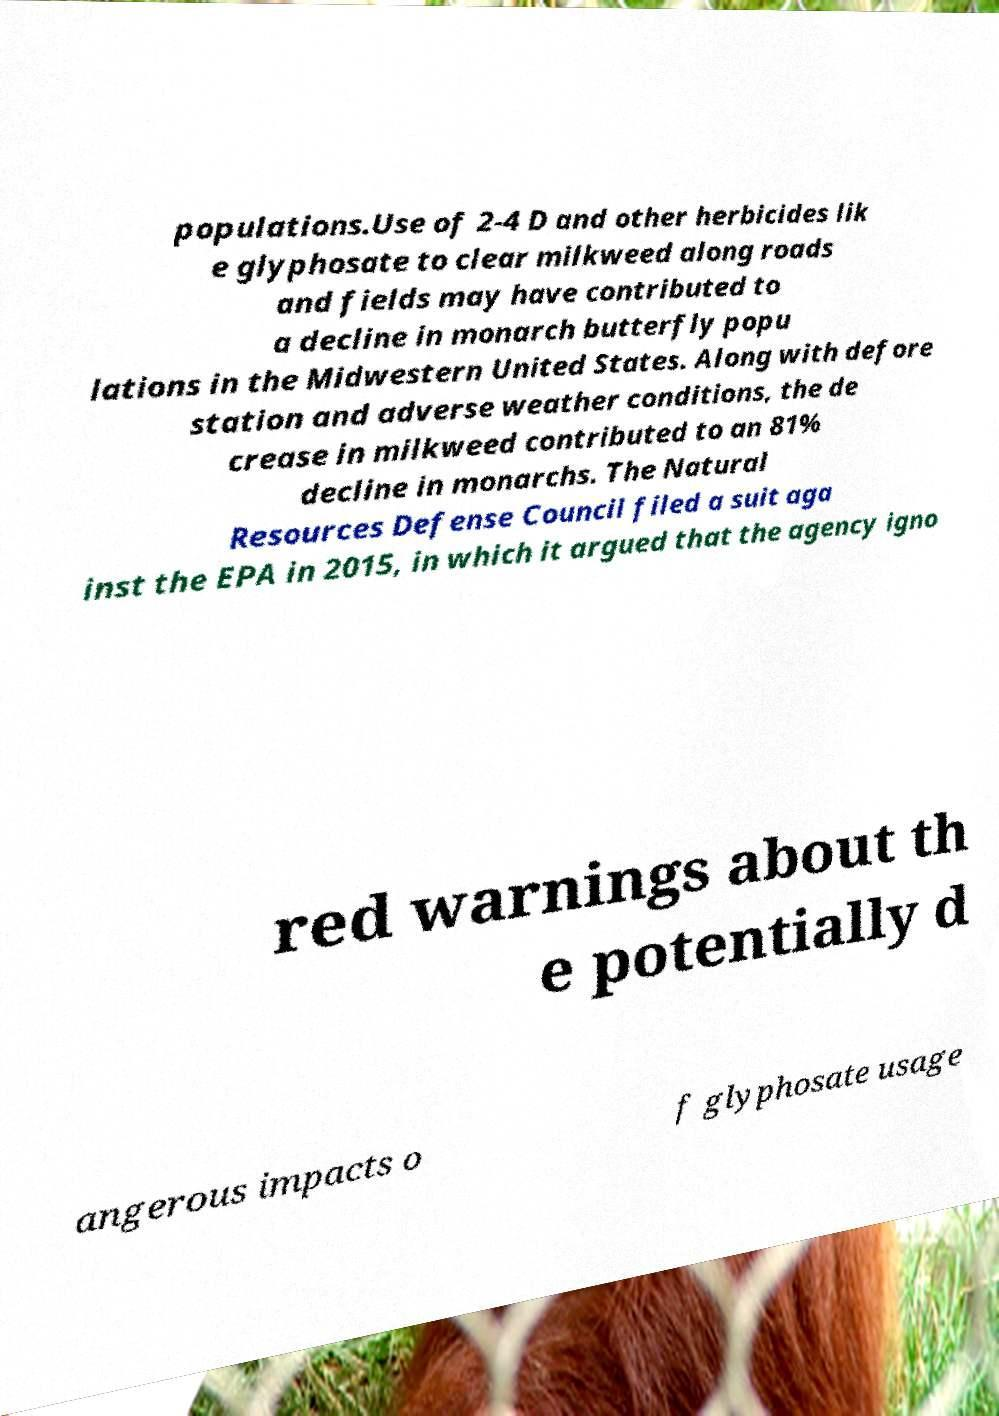For documentation purposes, I need the text within this image transcribed. Could you provide that? populations.Use of 2-4 D and other herbicides lik e glyphosate to clear milkweed along roads and fields may have contributed to a decline in monarch butterfly popu lations in the Midwestern United States. Along with defore station and adverse weather conditions, the de crease in milkweed contributed to an 81% decline in monarchs. The Natural Resources Defense Council filed a suit aga inst the EPA in 2015, in which it argued that the agency igno red warnings about th e potentially d angerous impacts o f glyphosate usage 